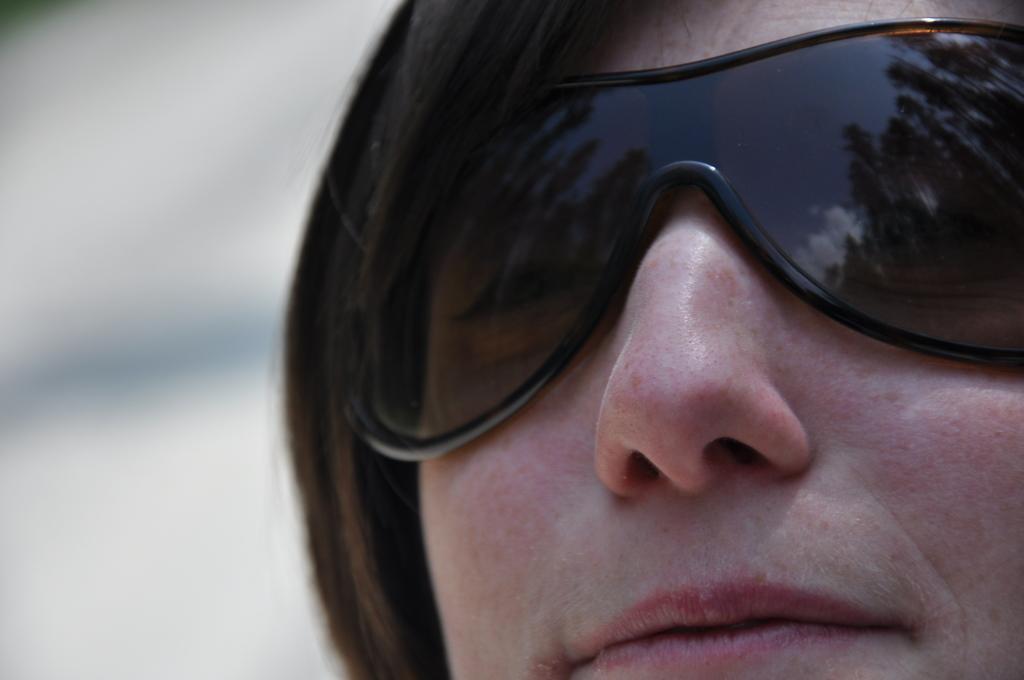In one or two sentences, can you explain what this image depicts? In this image there is a lady wearing goggles. 